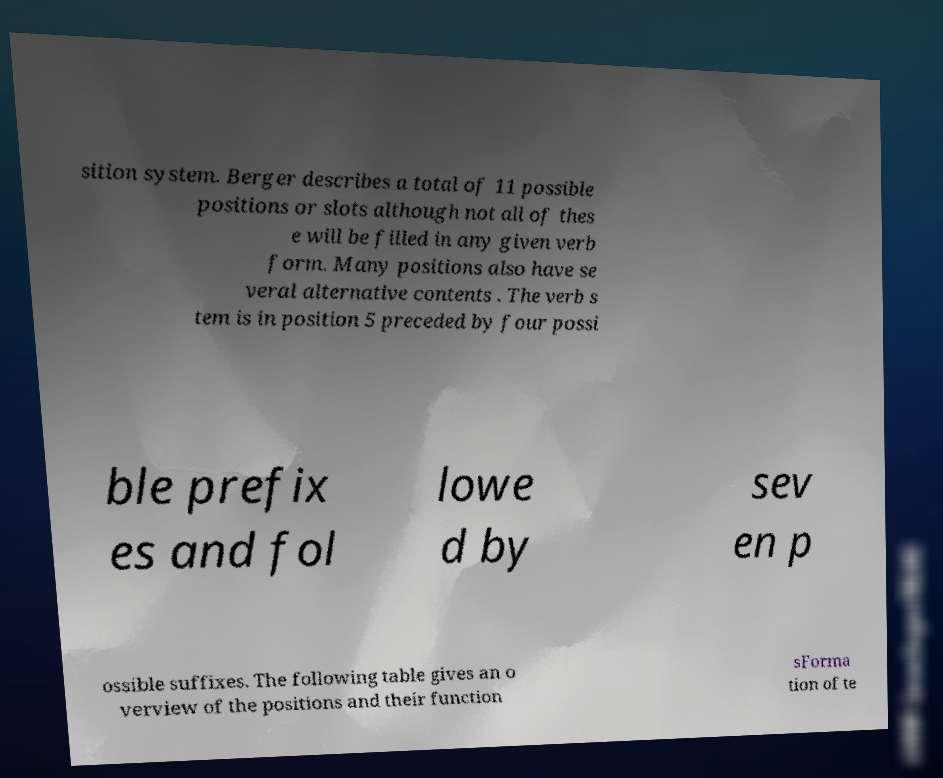Could you assist in decoding the text presented in this image and type it out clearly? sition system. Berger describes a total of 11 possible positions or slots although not all of thes e will be filled in any given verb form. Many positions also have se veral alternative contents . The verb s tem is in position 5 preceded by four possi ble prefix es and fol lowe d by sev en p ossible suffixes. The following table gives an o verview of the positions and their function sForma tion of te 